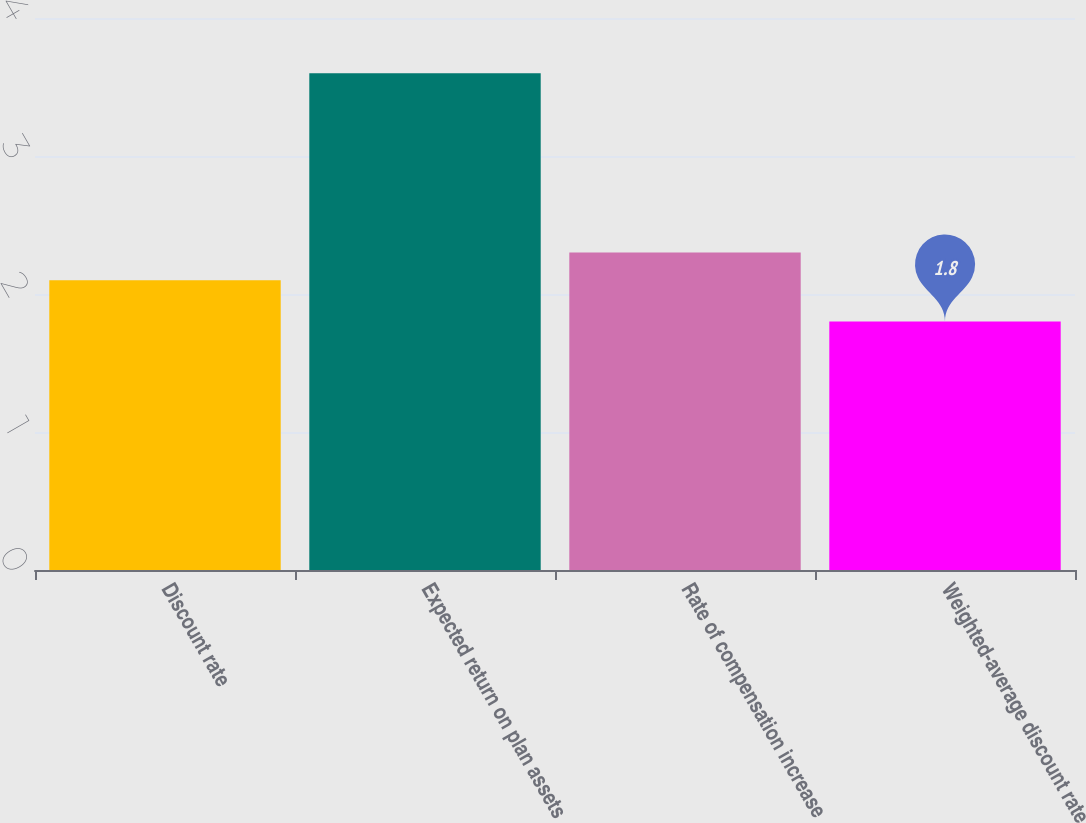<chart> <loc_0><loc_0><loc_500><loc_500><bar_chart><fcel>Discount rate<fcel>Expected return on plan assets<fcel>Rate of compensation increase<fcel>Weighted-average discount rate<nl><fcel>2.1<fcel>3.6<fcel>2.3<fcel>1.8<nl></chart> 